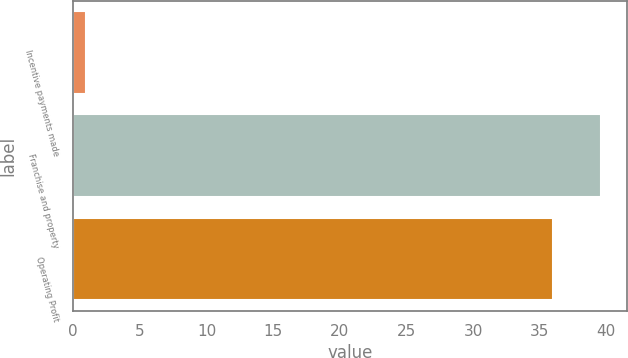Convert chart. <chart><loc_0><loc_0><loc_500><loc_500><bar_chart><fcel>Incentive payments made<fcel>Franchise and property<fcel>Operating Profit<nl><fcel>1<fcel>39.6<fcel>36<nl></chart> 